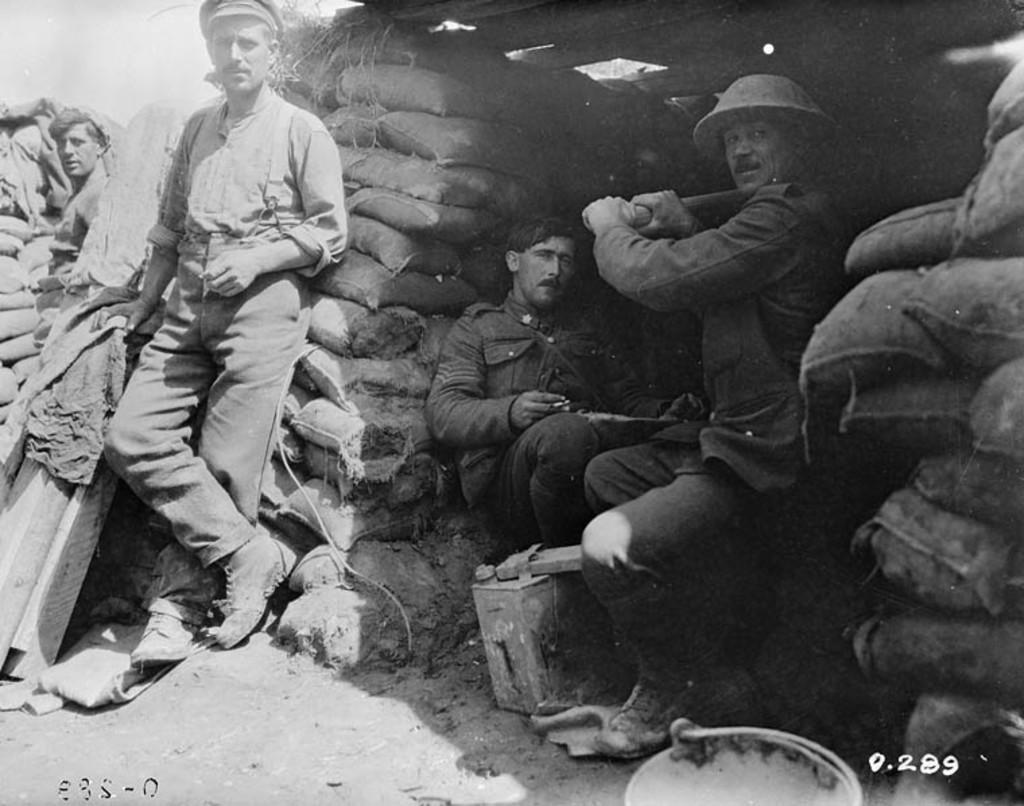How would you summarize this image in a sentence or two? This is a black and white image. I can see two people standing and two people sitting. These are the gunny sacks. There are few objects on the ground. At the bottom right side of the image, I can see the watermark. 